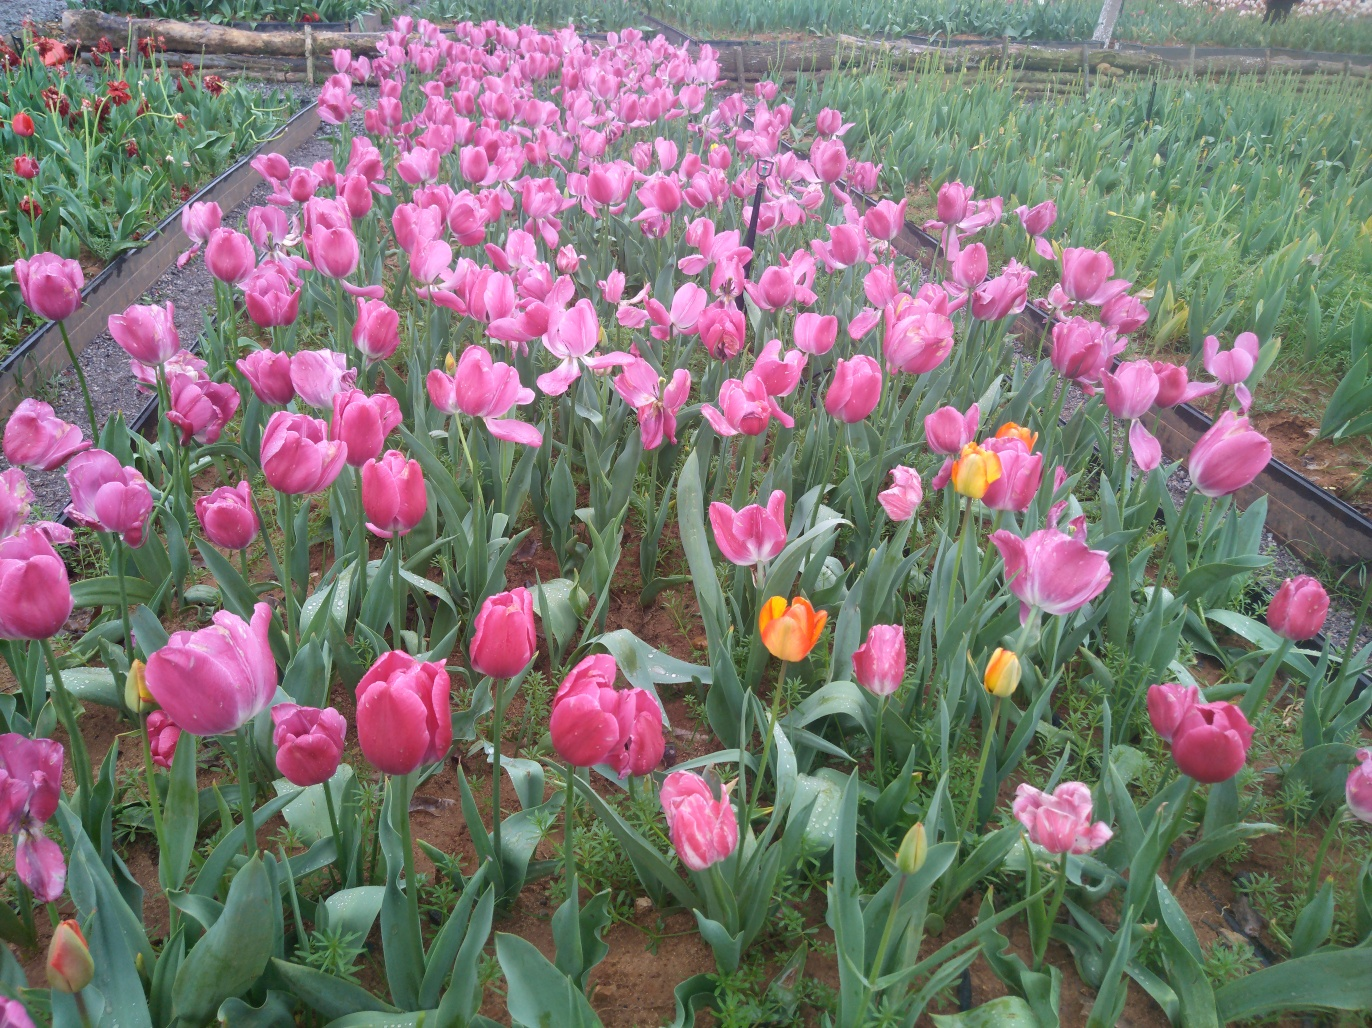Is there a reason why these tulips could be grown in such large numbers? Tulips are popular for both their aesthetic value and commercial demand. Large numbers might be grown for several reasons: for distribution to florists and markets, for use in festivals or garden shows, or for bulb production, where the flowers are later clipped to redirect energy into the bulbs to strengthen them before harvesting. In some regions, fields of tulips can also be a tourist attraction, drawing visitors who come to admire and walk among the vibrant blooms. 